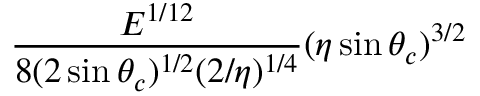<formula> <loc_0><loc_0><loc_500><loc_500>\frac { E ^ { 1 / 1 2 } } { 8 ( 2 \sin \theta _ { c } ) ^ { 1 / 2 } ( 2 / \eta ) ^ { 1 / 4 } } ( \eta \sin { \theta _ { c } } ) ^ { 3 / 2 }</formula> 